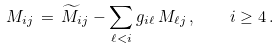<formula> <loc_0><loc_0><loc_500><loc_500>M _ { i j } \, = \, \widetilde { M } _ { i j } - \sum _ { \ell < i } g _ { i \ell } \, M _ { \ell j } \, , \quad i \geq 4 \, .</formula> 